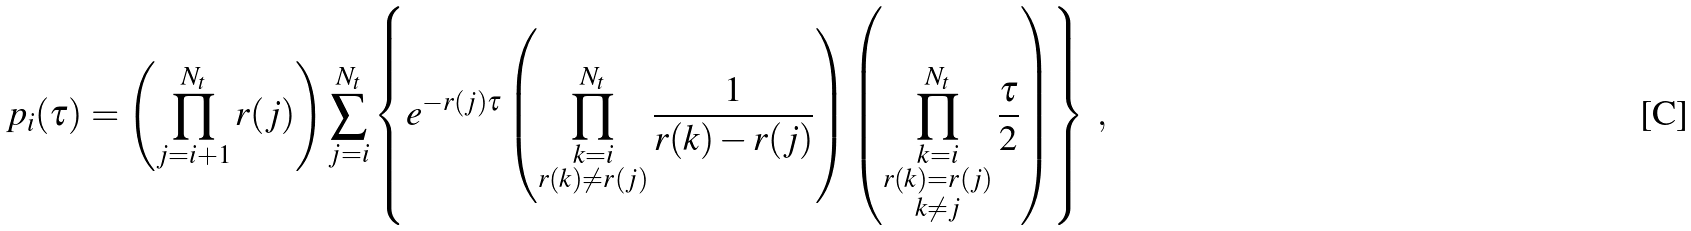Convert formula to latex. <formula><loc_0><loc_0><loc_500><loc_500>p _ { i } ( \tau ) = \left ( \prod _ { j = i + 1 } ^ { N _ { t } } r ( j ) \right ) \sum _ { j = i } ^ { N _ { t } } \left \{ e ^ { - r ( j ) \tau } \left ( \prod _ { \substack { k = i \\ r ( k ) \ne r ( j ) } } ^ { N _ { t } } \frac { 1 } { r ( k ) - r ( j ) } \right ) \left ( \prod _ { \substack { k = i \\ r ( k ) = r ( j ) \\ k \ne j } } ^ { N _ { t } } \frac { \tau } { 2 } \right ) \right \} \ ,</formula> 